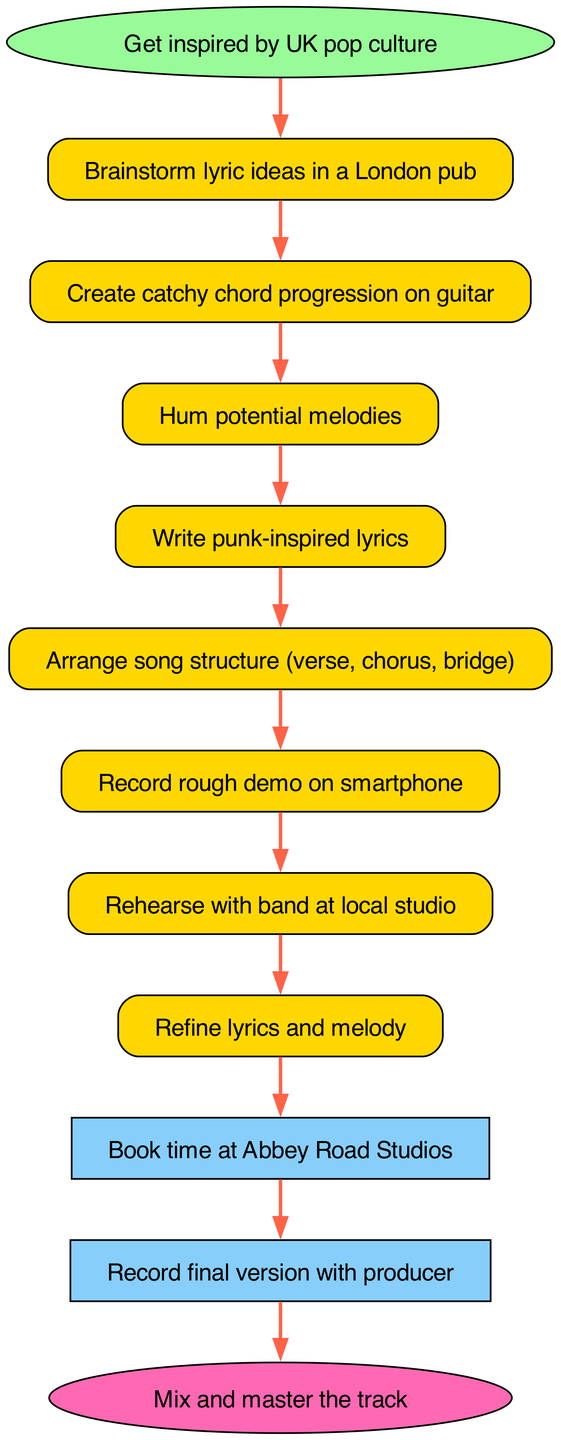What is the first step in the songwriting process? The first step, as indicated in the diagram, is "Get inspired by UK pop culture," which is the initial point before any other actions are taken.
Answer: Get inspired by UK pop culture How many steps are there in total? The diagram lists 12 distinct steps, counting from the start to the finish, which encompass the entire songwriting process.
Answer: 12 What is the last step in the process? The final step in the diagram is "Mix and master the track," indicating the completion of the song after all previous actions are taken.
Answer: Mix and master the track What do you do after writing punk-inspired lyrics? After writing the lyrics, the next action is to "Arrange song structure (verse, chorus, bridge)," showing the progression from lyrical content to structural organization.
Answer: Arrange song structure (verse, chorus, bridge) Which step follows rehearsing with the band? "Refine lyrics and melody" comes after the "Rehearse with band at local studio," reflecting the iterative process of improving the song after practicing with other musicians.
Answer: Refine lyrics and melody What is the connection between making a rough demo and rehearsing with the band? The flow chart shows that a rough demo recorded on a smartphone precedes the band rehearsal, emphasizing that you first capture your idea before refining it with the band.
Answer: Record rough demo on smartphone to Rehearse with band at local studio How many connections are there between nodes? The diagram shows a total of 11 connections, which link each step in the process to the next, guiding the flow from start to finish.
Answer: 11 What is the significance of booking time at Abbey Road Studios? Booking time at Abbey Road Studios is crucial as it represents the transition from the preparation and refining phase to the actual professional recording stage of the songwriting process.
Answer: Book time at Abbey Road Studios In which step do you hum potential melodies? "Hum potential melodies" occurs after creating a catchy chord progression on guitar, illustrating the progression from instrumental ideas to melodic creation.
Answer: Hum potential melodies 